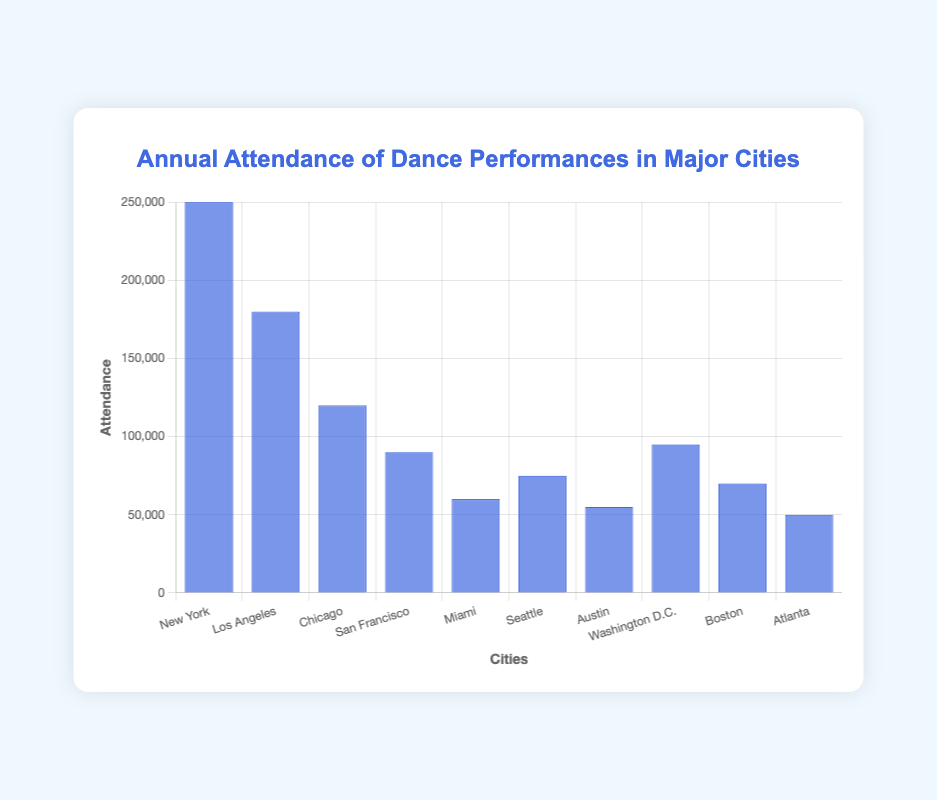What city has the highest annual attendance of dance performances? The bar chart shows various cities with their corresponding attendance numbers. New York has the tallest bar, indicating it has the highest attendance.
Answer: New York Which city has the lowest annual attendance of dance performances? The bar chart shows various cities with their corresponding attendance numbers. Atlanta has the shortest bar, indicating it has the lowest attendance.
Answer: Atlanta How much more is the annual attendance in New York compared to Miami? The bar for New York indicates an attendance of 250,000, while Miami's bar shows 60,000. The difference is 250,000 - 60,000.
Answer: 190,000 What is the total annual attendance of dance performances in Chicago, San Francisco, and Seattle? By summing the attendances for these cities: Chicago (120,000), San Francisco (90,000), and Seattle (75,000), the total is 120,000 + 90,000 + 75,000.
Answer: 285,000 What is the average annual attendance of dance performances across all the cities shown? Sum the attendance numbers for all cities: 250,000 (New York), 180,000 (Los Angeles), 120,000 (Chicago), 90,000 (San Francisco), 60,000 (Miami), 75,000 (Seattle), 55,000 (Austin), 95,000 (Washington D.C.), 70,000 (Boston), and 50,000 (Atlanta). The total is 1,045,000. Divide by the number of cities (10).
Answer: 104,500 Which cities have an annual attendance of fewer than 75,000 but more than 50,000? The cities with bars between these values are Austin (55,000) and Boston (70,000).
Answer: Austin, Boston What’s the difference in annual attendance between Washington D.C. and Seattle? The attendance for Washington D.C. is 95,000 and for Seattle, it is 75,000. The difference is 95,000 - 75,000.
Answer: 20,000 How does the attendance in Los Angeles compare to Chicago? The attendance for Los Angeles is 180,000, which is higher than Chicago's 120,000.
Answer: Los Angeles has higher attendance What is the combined attendance for cities with less than 100,000 annual attendance? Summing the attendances for San Francisco (90,000), Miami (60,000), Seattle (75,000), Austin (55,000), Boston (70,000), and Atlanta (50,000). The total is 400,000.
Answer: 400,000 